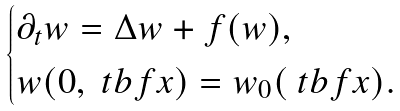Convert formula to latex. <formula><loc_0><loc_0><loc_500><loc_500>\begin{cases} \partial _ { t } w = \Delta w + f ( w ) , \\ w ( 0 , \ t b f { x } ) = w _ { 0 } ( \ t b f { x } ) . \end{cases}</formula> 